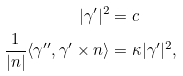<formula> <loc_0><loc_0><loc_500><loc_500>| \gamma ^ { \prime } | ^ { 2 } & = c \\ \frac { 1 } { | n | } \langle \gamma ^ { \prime \prime } , \gamma ^ { \prime } \times n \rangle & = \kappa | \gamma ^ { \prime } | ^ { 2 } ,</formula> 